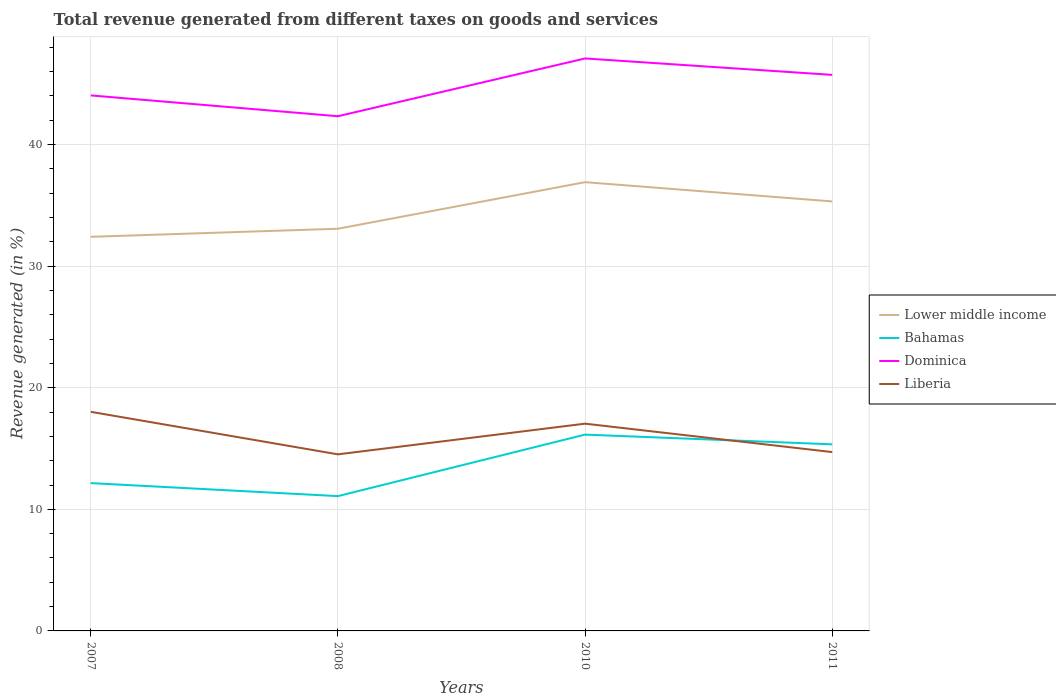How many different coloured lines are there?
Ensure brevity in your answer.  4. Across all years, what is the maximum total revenue generated in Bahamas?
Provide a succinct answer. 11.09. What is the total total revenue generated in Liberia in the graph?
Your answer should be compact. 0.97. What is the difference between the highest and the second highest total revenue generated in Lower middle income?
Ensure brevity in your answer.  4.5. What is the difference between the highest and the lowest total revenue generated in Bahamas?
Your answer should be compact. 2. How many lines are there?
Offer a terse response. 4. How many years are there in the graph?
Your response must be concise. 4. Are the values on the major ticks of Y-axis written in scientific E-notation?
Your answer should be very brief. No. Does the graph contain any zero values?
Offer a terse response. No. What is the title of the graph?
Make the answer very short. Total revenue generated from different taxes on goods and services. Does "Brunei Darussalam" appear as one of the legend labels in the graph?
Your answer should be very brief. No. What is the label or title of the X-axis?
Keep it short and to the point. Years. What is the label or title of the Y-axis?
Your answer should be very brief. Revenue generated (in %). What is the Revenue generated (in %) in Lower middle income in 2007?
Provide a short and direct response. 32.41. What is the Revenue generated (in %) of Bahamas in 2007?
Your answer should be very brief. 12.16. What is the Revenue generated (in %) of Dominica in 2007?
Give a very brief answer. 44.04. What is the Revenue generated (in %) in Liberia in 2007?
Provide a succinct answer. 18.02. What is the Revenue generated (in %) in Lower middle income in 2008?
Ensure brevity in your answer.  33.08. What is the Revenue generated (in %) of Bahamas in 2008?
Provide a succinct answer. 11.09. What is the Revenue generated (in %) in Dominica in 2008?
Your answer should be very brief. 42.33. What is the Revenue generated (in %) of Liberia in 2008?
Provide a succinct answer. 14.52. What is the Revenue generated (in %) in Lower middle income in 2010?
Give a very brief answer. 36.91. What is the Revenue generated (in %) in Bahamas in 2010?
Keep it short and to the point. 16.15. What is the Revenue generated (in %) in Dominica in 2010?
Your response must be concise. 47.08. What is the Revenue generated (in %) of Liberia in 2010?
Make the answer very short. 17.05. What is the Revenue generated (in %) of Lower middle income in 2011?
Offer a terse response. 35.33. What is the Revenue generated (in %) in Bahamas in 2011?
Your answer should be very brief. 15.35. What is the Revenue generated (in %) of Dominica in 2011?
Your answer should be compact. 45.73. What is the Revenue generated (in %) of Liberia in 2011?
Make the answer very short. 14.71. Across all years, what is the maximum Revenue generated (in %) in Lower middle income?
Provide a short and direct response. 36.91. Across all years, what is the maximum Revenue generated (in %) of Bahamas?
Your answer should be compact. 16.15. Across all years, what is the maximum Revenue generated (in %) in Dominica?
Provide a succinct answer. 47.08. Across all years, what is the maximum Revenue generated (in %) of Liberia?
Provide a short and direct response. 18.02. Across all years, what is the minimum Revenue generated (in %) in Lower middle income?
Make the answer very short. 32.41. Across all years, what is the minimum Revenue generated (in %) in Bahamas?
Ensure brevity in your answer.  11.09. Across all years, what is the minimum Revenue generated (in %) of Dominica?
Make the answer very short. 42.33. Across all years, what is the minimum Revenue generated (in %) in Liberia?
Your answer should be very brief. 14.52. What is the total Revenue generated (in %) in Lower middle income in the graph?
Your answer should be very brief. 137.72. What is the total Revenue generated (in %) of Bahamas in the graph?
Keep it short and to the point. 54.74. What is the total Revenue generated (in %) in Dominica in the graph?
Give a very brief answer. 179.19. What is the total Revenue generated (in %) in Liberia in the graph?
Ensure brevity in your answer.  64.3. What is the difference between the Revenue generated (in %) of Lower middle income in 2007 and that in 2008?
Ensure brevity in your answer.  -0.66. What is the difference between the Revenue generated (in %) of Bahamas in 2007 and that in 2008?
Offer a very short reply. 1.07. What is the difference between the Revenue generated (in %) in Dominica in 2007 and that in 2008?
Your answer should be compact. 1.71. What is the difference between the Revenue generated (in %) in Liberia in 2007 and that in 2008?
Offer a terse response. 3.5. What is the difference between the Revenue generated (in %) in Lower middle income in 2007 and that in 2010?
Provide a succinct answer. -4.5. What is the difference between the Revenue generated (in %) in Bahamas in 2007 and that in 2010?
Offer a very short reply. -3.99. What is the difference between the Revenue generated (in %) in Dominica in 2007 and that in 2010?
Your response must be concise. -3.04. What is the difference between the Revenue generated (in %) in Liberia in 2007 and that in 2010?
Ensure brevity in your answer.  0.97. What is the difference between the Revenue generated (in %) of Lower middle income in 2007 and that in 2011?
Ensure brevity in your answer.  -2.91. What is the difference between the Revenue generated (in %) of Bahamas in 2007 and that in 2011?
Ensure brevity in your answer.  -3.19. What is the difference between the Revenue generated (in %) of Dominica in 2007 and that in 2011?
Provide a short and direct response. -1.69. What is the difference between the Revenue generated (in %) in Liberia in 2007 and that in 2011?
Your answer should be very brief. 3.31. What is the difference between the Revenue generated (in %) of Lower middle income in 2008 and that in 2010?
Ensure brevity in your answer.  -3.83. What is the difference between the Revenue generated (in %) of Bahamas in 2008 and that in 2010?
Your answer should be compact. -5.06. What is the difference between the Revenue generated (in %) of Dominica in 2008 and that in 2010?
Give a very brief answer. -4.75. What is the difference between the Revenue generated (in %) in Liberia in 2008 and that in 2010?
Provide a succinct answer. -2.52. What is the difference between the Revenue generated (in %) of Lower middle income in 2008 and that in 2011?
Ensure brevity in your answer.  -2.25. What is the difference between the Revenue generated (in %) of Bahamas in 2008 and that in 2011?
Your answer should be very brief. -4.26. What is the difference between the Revenue generated (in %) of Dominica in 2008 and that in 2011?
Provide a short and direct response. -3.4. What is the difference between the Revenue generated (in %) in Liberia in 2008 and that in 2011?
Your response must be concise. -0.19. What is the difference between the Revenue generated (in %) in Lower middle income in 2010 and that in 2011?
Your answer should be very brief. 1.58. What is the difference between the Revenue generated (in %) of Bahamas in 2010 and that in 2011?
Provide a succinct answer. 0.8. What is the difference between the Revenue generated (in %) in Dominica in 2010 and that in 2011?
Offer a very short reply. 1.35. What is the difference between the Revenue generated (in %) in Liberia in 2010 and that in 2011?
Give a very brief answer. 2.34. What is the difference between the Revenue generated (in %) in Lower middle income in 2007 and the Revenue generated (in %) in Bahamas in 2008?
Keep it short and to the point. 21.33. What is the difference between the Revenue generated (in %) in Lower middle income in 2007 and the Revenue generated (in %) in Dominica in 2008?
Your answer should be very brief. -9.92. What is the difference between the Revenue generated (in %) of Lower middle income in 2007 and the Revenue generated (in %) of Liberia in 2008?
Give a very brief answer. 17.89. What is the difference between the Revenue generated (in %) in Bahamas in 2007 and the Revenue generated (in %) in Dominica in 2008?
Offer a terse response. -30.18. What is the difference between the Revenue generated (in %) in Bahamas in 2007 and the Revenue generated (in %) in Liberia in 2008?
Ensure brevity in your answer.  -2.37. What is the difference between the Revenue generated (in %) in Dominica in 2007 and the Revenue generated (in %) in Liberia in 2008?
Your answer should be compact. 29.52. What is the difference between the Revenue generated (in %) in Lower middle income in 2007 and the Revenue generated (in %) in Bahamas in 2010?
Offer a very short reply. 16.27. What is the difference between the Revenue generated (in %) in Lower middle income in 2007 and the Revenue generated (in %) in Dominica in 2010?
Give a very brief answer. -14.67. What is the difference between the Revenue generated (in %) in Lower middle income in 2007 and the Revenue generated (in %) in Liberia in 2010?
Provide a short and direct response. 15.37. What is the difference between the Revenue generated (in %) of Bahamas in 2007 and the Revenue generated (in %) of Dominica in 2010?
Keep it short and to the point. -34.93. What is the difference between the Revenue generated (in %) of Bahamas in 2007 and the Revenue generated (in %) of Liberia in 2010?
Give a very brief answer. -4.89. What is the difference between the Revenue generated (in %) of Dominica in 2007 and the Revenue generated (in %) of Liberia in 2010?
Keep it short and to the point. 27. What is the difference between the Revenue generated (in %) in Lower middle income in 2007 and the Revenue generated (in %) in Bahamas in 2011?
Offer a terse response. 17.07. What is the difference between the Revenue generated (in %) in Lower middle income in 2007 and the Revenue generated (in %) in Dominica in 2011?
Your answer should be very brief. -13.32. What is the difference between the Revenue generated (in %) of Lower middle income in 2007 and the Revenue generated (in %) of Liberia in 2011?
Make the answer very short. 17.71. What is the difference between the Revenue generated (in %) of Bahamas in 2007 and the Revenue generated (in %) of Dominica in 2011?
Your response must be concise. -33.58. What is the difference between the Revenue generated (in %) of Bahamas in 2007 and the Revenue generated (in %) of Liberia in 2011?
Keep it short and to the point. -2.55. What is the difference between the Revenue generated (in %) in Dominica in 2007 and the Revenue generated (in %) in Liberia in 2011?
Your response must be concise. 29.34. What is the difference between the Revenue generated (in %) of Lower middle income in 2008 and the Revenue generated (in %) of Bahamas in 2010?
Your response must be concise. 16.93. What is the difference between the Revenue generated (in %) of Lower middle income in 2008 and the Revenue generated (in %) of Dominica in 2010?
Keep it short and to the point. -14.01. What is the difference between the Revenue generated (in %) of Lower middle income in 2008 and the Revenue generated (in %) of Liberia in 2010?
Give a very brief answer. 16.03. What is the difference between the Revenue generated (in %) in Bahamas in 2008 and the Revenue generated (in %) in Dominica in 2010?
Provide a short and direct response. -36. What is the difference between the Revenue generated (in %) in Bahamas in 2008 and the Revenue generated (in %) in Liberia in 2010?
Offer a terse response. -5.96. What is the difference between the Revenue generated (in %) of Dominica in 2008 and the Revenue generated (in %) of Liberia in 2010?
Give a very brief answer. 25.29. What is the difference between the Revenue generated (in %) in Lower middle income in 2008 and the Revenue generated (in %) in Bahamas in 2011?
Your answer should be compact. 17.73. What is the difference between the Revenue generated (in %) in Lower middle income in 2008 and the Revenue generated (in %) in Dominica in 2011?
Provide a succinct answer. -12.65. What is the difference between the Revenue generated (in %) in Lower middle income in 2008 and the Revenue generated (in %) in Liberia in 2011?
Ensure brevity in your answer.  18.37. What is the difference between the Revenue generated (in %) of Bahamas in 2008 and the Revenue generated (in %) of Dominica in 2011?
Your answer should be very brief. -34.65. What is the difference between the Revenue generated (in %) in Bahamas in 2008 and the Revenue generated (in %) in Liberia in 2011?
Give a very brief answer. -3.62. What is the difference between the Revenue generated (in %) of Dominica in 2008 and the Revenue generated (in %) of Liberia in 2011?
Your answer should be compact. 27.62. What is the difference between the Revenue generated (in %) of Lower middle income in 2010 and the Revenue generated (in %) of Bahamas in 2011?
Your answer should be very brief. 21.56. What is the difference between the Revenue generated (in %) of Lower middle income in 2010 and the Revenue generated (in %) of Dominica in 2011?
Ensure brevity in your answer.  -8.82. What is the difference between the Revenue generated (in %) in Lower middle income in 2010 and the Revenue generated (in %) in Liberia in 2011?
Give a very brief answer. 22.2. What is the difference between the Revenue generated (in %) of Bahamas in 2010 and the Revenue generated (in %) of Dominica in 2011?
Your answer should be very brief. -29.59. What is the difference between the Revenue generated (in %) in Bahamas in 2010 and the Revenue generated (in %) in Liberia in 2011?
Provide a succinct answer. 1.44. What is the difference between the Revenue generated (in %) of Dominica in 2010 and the Revenue generated (in %) of Liberia in 2011?
Offer a very short reply. 32.37. What is the average Revenue generated (in %) of Lower middle income per year?
Your response must be concise. 34.43. What is the average Revenue generated (in %) of Bahamas per year?
Provide a short and direct response. 13.68. What is the average Revenue generated (in %) in Dominica per year?
Make the answer very short. 44.8. What is the average Revenue generated (in %) in Liberia per year?
Your answer should be compact. 16.07. In the year 2007, what is the difference between the Revenue generated (in %) of Lower middle income and Revenue generated (in %) of Bahamas?
Keep it short and to the point. 20.26. In the year 2007, what is the difference between the Revenue generated (in %) of Lower middle income and Revenue generated (in %) of Dominica?
Keep it short and to the point. -11.63. In the year 2007, what is the difference between the Revenue generated (in %) of Lower middle income and Revenue generated (in %) of Liberia?
Your answer should be compact. 14.39. In the year 2007, what is the difference between the Revenue generated (in %) of Bahamas and Revenue generated (in %) of Dominica?
Your answer should be compact. -31.89. In the year 2007, what is the difference between the Revenue generated (in %) of Bahamas and Revenue generated (in %) of Liberia?
Keep it short and to the point. -5.86. In the year 2007, what is the difference between the Revenue generated (in %) in Dominica and Revenue generated (in %) in Liberia?
Your answer should be very brief. 26.02. In the year 2008, what is the difference between the Revenue generated (in %) in Lower middle income and Revenue generated (in %) in Bahamas?
Your answer should be compact. 21.99. In the year 2008, what is the difference between the Revenue generated (in %) in Lower middle income and Revenue generated (in %) in Dominica?
Provide a short and direct response. -9.25. In the year 2008, what is the difference between the Revenue generated (in %) in Lower middle income and Revenue generated (in %) in Liberia?
Give a very brief answer. 18.55. In the year 2008, what is the difference between the Revenue generated (in %) of Bahamas and Revenue generated (in %) of Dominica?
Offer a very short reply. -31.24. In the year 2008, what is the difference between the Revenue generated (in %) in Bahamas and Revenue generated (in %) in Liberia?
Ensure brevity in your answer.  -3.44. In the year 2008, what is the difference between the Revenue generated (in %) of Dominica and Revenue generated (in %) of Liberia?
Keep it short and to the point. 27.81. In the year 2010, what is the difference between the Revenue generated (in %) of Lower middle income and Revenue generated (in %) of Bahamas?
Your answer should be very brief. 20.76. In the year 2010, what is the difference between the Revenue generated (in %) of Lower middle income and Revenue generated (in %) of Dominica?
Keep it short and to the point. -10.17. In the year 2010, what is the difference between the Revenue generated (in %) in Lower middle income and Revenue generated (in %) in Liberia?
Your answer should be compact. 19.86. In the year 2010, what is the difference between the Revenue generated (in %) in Bahamas and Revenue generated (in %) in Dominica?
Keep it short and to the point. -30.94. In the year 2010, what is the difference between the Revenue generated (in %) of Bahamas and Revenue generated (in %) of Liberia?
Make the answer very short. -0.9. In the year 2010, what is the difference between the Revenue generated (in %) of Dominica and Revenue generated (in %) of Liberia?
Provide a succinct answer. 30.04. In the year 2011, what is the difference between the Revenue generated (in %) of Lower middle income and Revenue generated (in %) of Bahamas?
Keep it short and to the point. 19.98. In the year 2011, what is the difference between the Revenue generated (in %) in Lower middle income and Revenue generated (in %) in Dominica?
Provide a short and direct response. -10.41. In the year 2011, what is the difference between the Revenue generated (in %) of Lower middle income and Revenue generated (in %) of Liberia?
Provide a short and direct response. 20.62. In the year 2011, what is the difference between the Revenue generated (in %) in Bahamas and Revenue generated (in %) in Dominica?
Ensure brevity in your answer.  -30.39. In the year 2011, what is the difference between the Revenue generated (in %) in Bahamas and Revenue generated (in %) in Liberia?
Provide a succinct answer. 0.64. In the year 2011, what is the difference between the Revenue generated (in %) of Dominica and Revenue generated (in %) of Liberia?
Your answer should be very brief. 31.02. What is the ratio of the Revenue generated (in %) in Lower middle income in 2007 to that in 2008?
Provide a succinct answer. 0.98. What is the ratio of the Revenue generated (in %) of Bahamas in 2007 to that in 2008?
Your answer should be compact. 1.1. What is the ratio of the Revenue generated (in %) in Dominica in 2007 to that in 2008?
Provide a short and direct response. 1.04. What is the ratio of the Revenue generated (in %) in Liberia in 2007 to that in 2008?
Your response must be concise. 1.24. What is the ratio of the Revenue generated (in %) of Lower middle income in 2007 to that in 2010?
Your response must be concise. 0.88. What is the ratio of the Revenue generated (in %) in Bahamas in 2007 to that in 2010?
Offer a terse response. 0.75. What is the ratio of the Revenue generated (in %) in Dominica in 2007 to that in 2010?
Your answer should be compact. 0.94. What is the ratio of the Revenue generated (in %) of Liberia in 2007 to that in 2010?
Keep it short and to the point. 1.06. What is the ratio of the Revenue generated (in %) of Lower middle income in 2007 to that in 2011?
Your response must be concise. 0.92. What is the ratio of the Revenue generated (in %) in Bahamas in 2007 to that in 2011?
Your response must be concise. 0.79. What is the ratio of the Revenue generated (in %) in Dominica in 2007 to that in 2011?
Offer a terse response. 0.96. What is the ratio of the Revenue generated (in %) of Liberia in 2007 to that in 2011?
Ensure brevity in your answer.  1.23. What is the ratio of the Revenue generated (in %) in Lower middle income in 2008 to that in 2010?
Make the answer very short. 0.9. What is the ratio of the Revenue generated (in %) of Bahamas in 2008 to that in 2010?
Offer a terse response. 0.69. What is the ratio of the Revenue generated (in %) of Dominica in 2008 to that in 2010?
Offer a very short reply. 0.9. What is the ratio of the Revenue generated (in %) of Liberia in 2008 to that in 2010?
Provide a short and direct response. 0.85. What is the ratio of the Revenue generated (in %) in Lower middle income in 2008 to that in 2011?
Ensure brevity in your answer.  0.94. What is the ratio of the Revenue generated (in %) in Bahamas in 2008 to that in 2011?
Your answer should be compact. 0.72. What is the ratio of the Revenue generated (in %) of Dominica in 2008 to that in 2011?
Make the answer very short. 0.93. What is the ratio of the Revenue generated (in %) of Liberia in 2008 to that in 2011?
Make the answer very short. 0.99. What is the ratio of the Revenue generated (in %) of Lower middle income in 2010 to that in 2011?
Give a very brief answer. 1.04. What is the ratio of the Revenue generated (in %) in Bahamas in 2010 to that in 2011?
Your answer should be very brief. 1.05. What is the ratio of the Revenue generated (in %) of Dominica in 2010 to that in 2011?
Your response must be concise. 1.03. What is the ratio of the Revenue generated (in %) of Liberia in 2010 to that in 2011?
Your answer should be very brief. 1.16. What is the difference between the highest and the second highest Revenue generated (in %) of Lower middle income?
Offer a very short reply. 1.58. What is the difference between the highest and the second highest Revenue generated (in %) of Bahamas?
Your answer should be compact. 0.8. What is the difference between the highest and the second highest Revenue generated (in %) of Dominica?
Provide a succinct answer. 1.35. What is the difference between the highest and the second highest Revenue generated (in %) of Liberia?
Your answer should be very brief. 0.97. What is the difference between the highest and the lowest Revenue generated (in %) of Lower middle income?
Offer a very short reply. 4.5. What is the difference between the highest and the lowest Revenue generated (in %) in Bahamas?
Give a very brief answer. 5.06. What is the difference between the highest and the lowest Revenue generated (in %) in Dominica?
Provide a succinct answer. 4.75. What is the difference between the highest and the lowest Revenue generated (in %) of Liberia?
Ensure brevity in your answer.  3.5. 